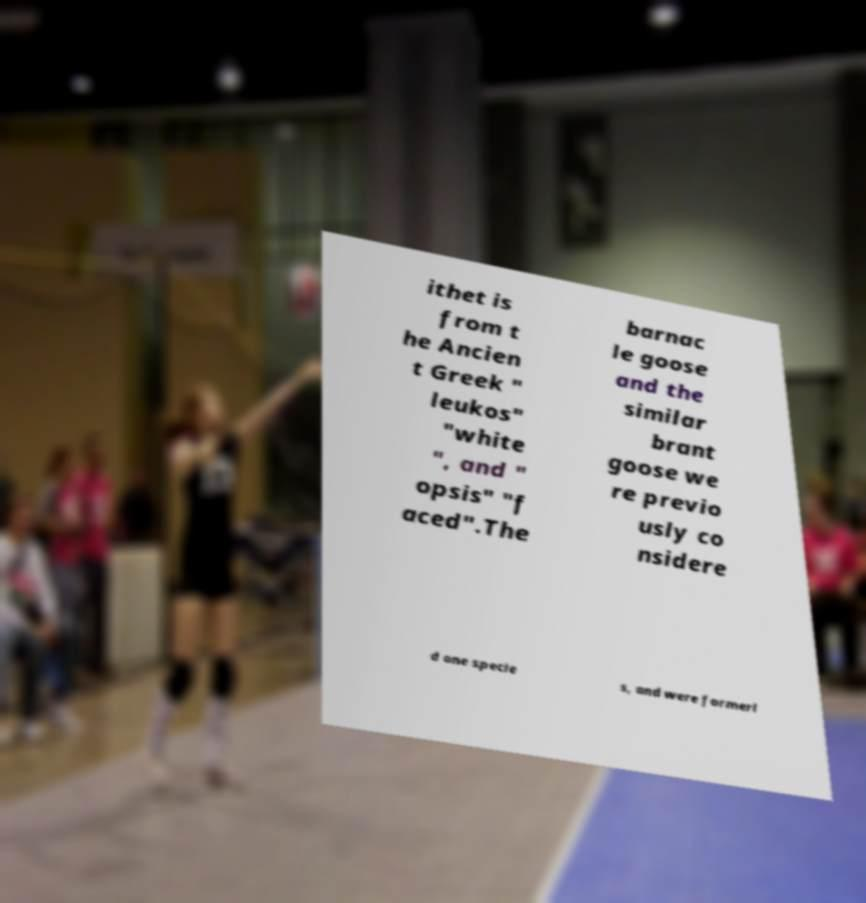I need the written content from this picture converted into text. Can you do that? ithet is from t he Ancien t Greek " leukos" "white ", and " opsis" "f aced".The barnac le goose and the similar brant goose we re previo usly co nsidere d one specie s, and were formerl 